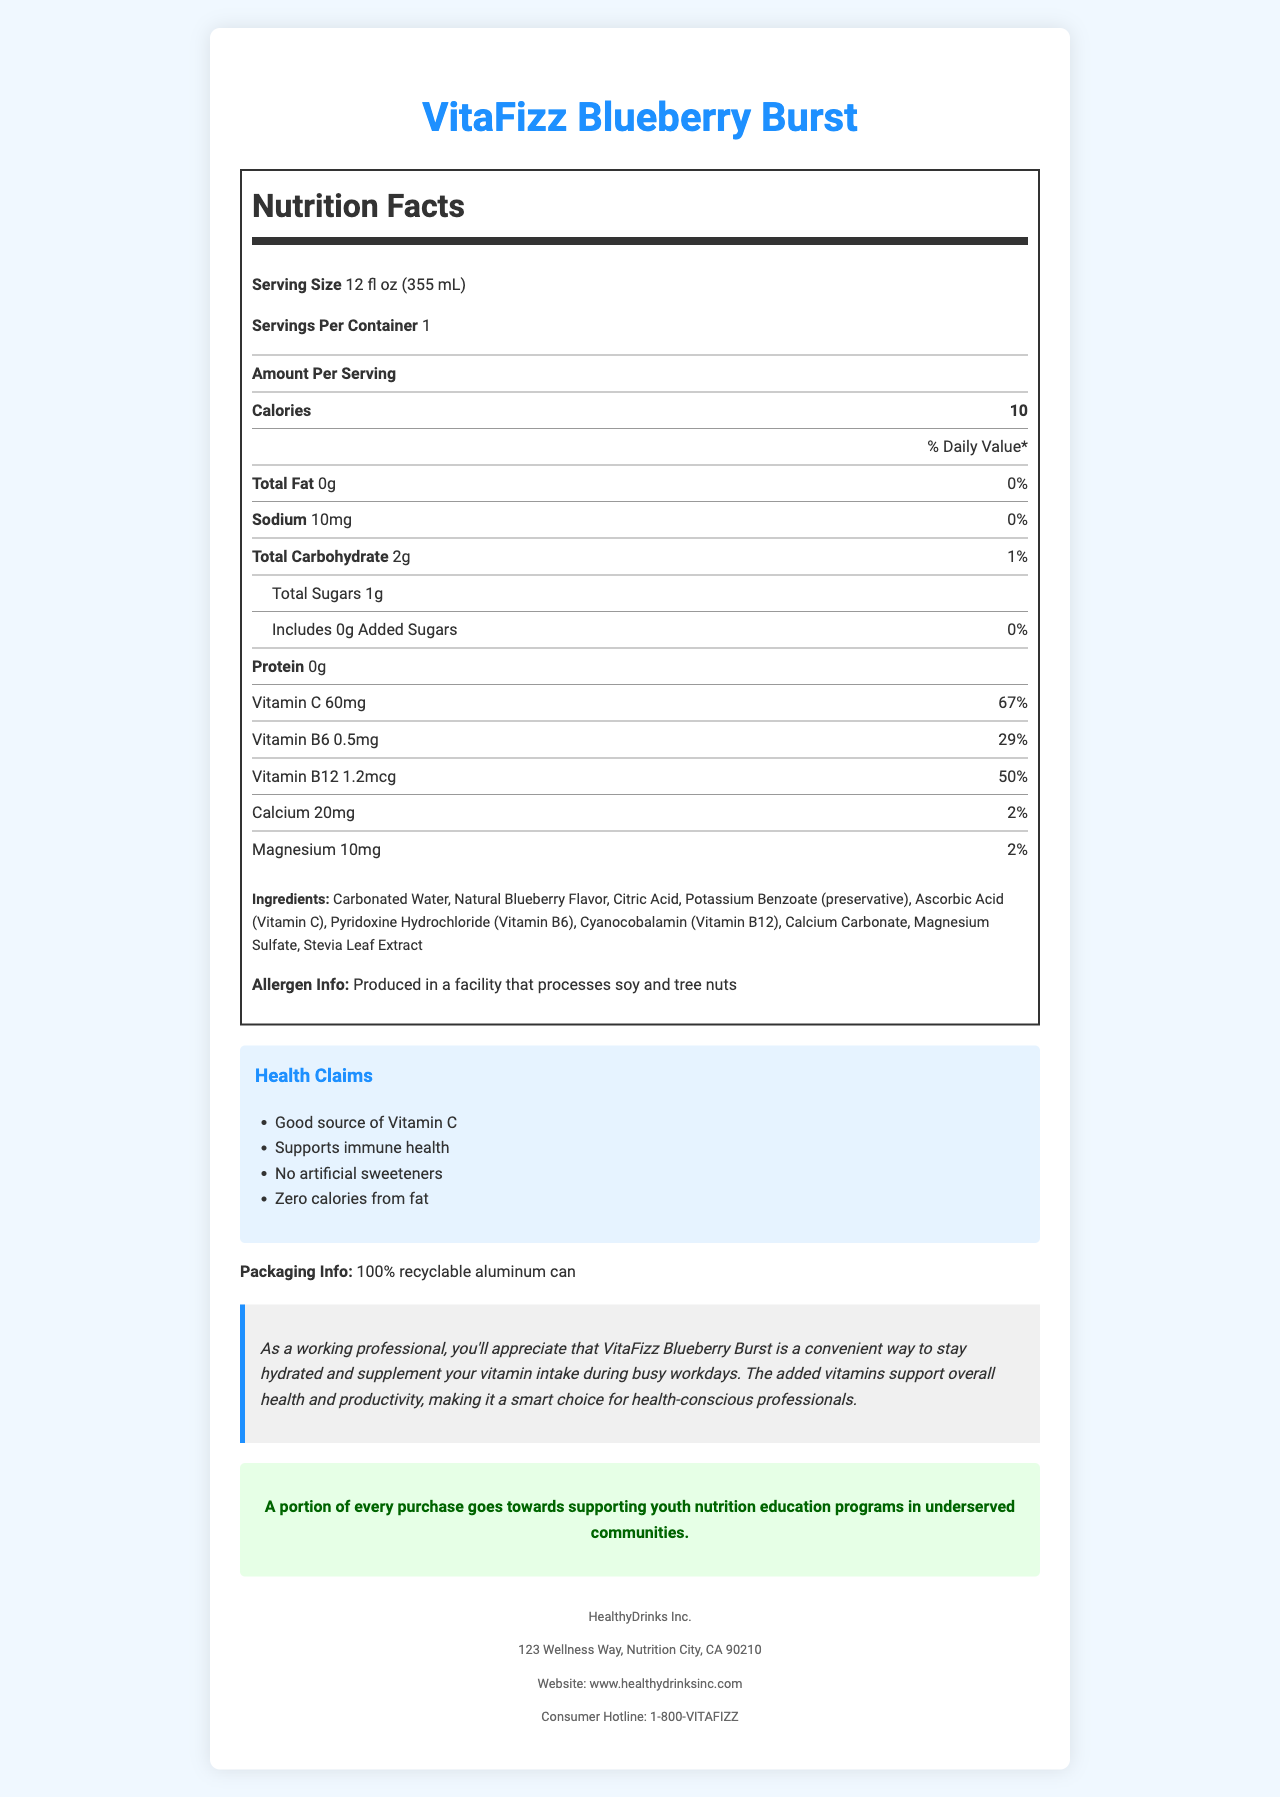Who is the manufacturer of VitaFizz Blueberry Burst? The company information section states that HealthyDrinks Inc. is the manufacturer of VitaFizz Blueberry Burst.
Answer: HealthyDrinks Inc. What is the serving size of VitaFizz Blueberry Burst? The nutrition label specifies the serving size as 12 fl oz (355 mL).
Answer: 12 fl oz (355 mL) How many calories are in one serving of VitaFizz Blueberry Burst? The nutrition facts state that there are 10 calories per serving.
Answer: 10 How much Vitamin C does one serving provide and what is its daily value percentage? The nutrition label indicates that one serving provides 60mg of Vitamin C, which is 67% of the daily value.
Answer: 60mg, 67% What are the first two ingredients listed for VitaFizz Blueberry Burst? The ingredients section lists Carbonated Water and Natural Blueberry Flavor as the first two ingredients.
Answer: Carbonated Water, Natural Blueberry Flavor Which mineral in VitaFizz Blueberry Burst has the highest amount per serving? A. Calcium B. Sodium C. Magnesium Calcium has 20mg per serving, which is higher than Sodium (10mg) and Magnesium (10mg).
Answer: A. Calcium What are the daily values of Vitamin B6 and Vitamin B12 in one serving? A. 29% and 67% B. 29% and 50% C. 50% and 29% The nutrition label shows the daily values as 29% for Vitamin B6 and 50% for Vitamin B12.
Answer: B. 29% and 50% Does VitaFizz Blueberry Burst contain any added sugars? The nutrition facts indicate there are 0g of added sugars in Vitafizz Blueberry Burst.
Answer: No Is VitaFizz Blueberry Burst free from artificial sweeteners? One of the health claims on the document states that the product has no artificial sweeteners.
Answer: Yes Summarize the main features of VitaFizz Blueberry Burst. The document details the product "VitaFizz Blueberry Burst," its nutritional content, ingredients, health benefits, packaging, and company commitments. It highlights key nutrients and vitamins, claims of supporting immune health, and its eco-friendly packaging. It also notes the product supports educational programs through its sales.
Answer: VitaFizz Blueberry Burst is a vitamin-fortified sparkling water with natural blueberry flavor. It has 10 calories per 12 fl oz serving and is a good source of Vitamin C, supporting immune health. The product includes essential vitamins and minerals, has no artificial sweeteners, and is packaged in a 100% recyclable aluminum can. Additionally, a portion of each purchase supports youth nutrition education programs in underserved communities. What is the exact flavor of VitaFizz Blueberry Burst? The document only specifies "Natural Blueberry Flavor," but does not provide the exact flavor profile details.
Answer: Not enough information 